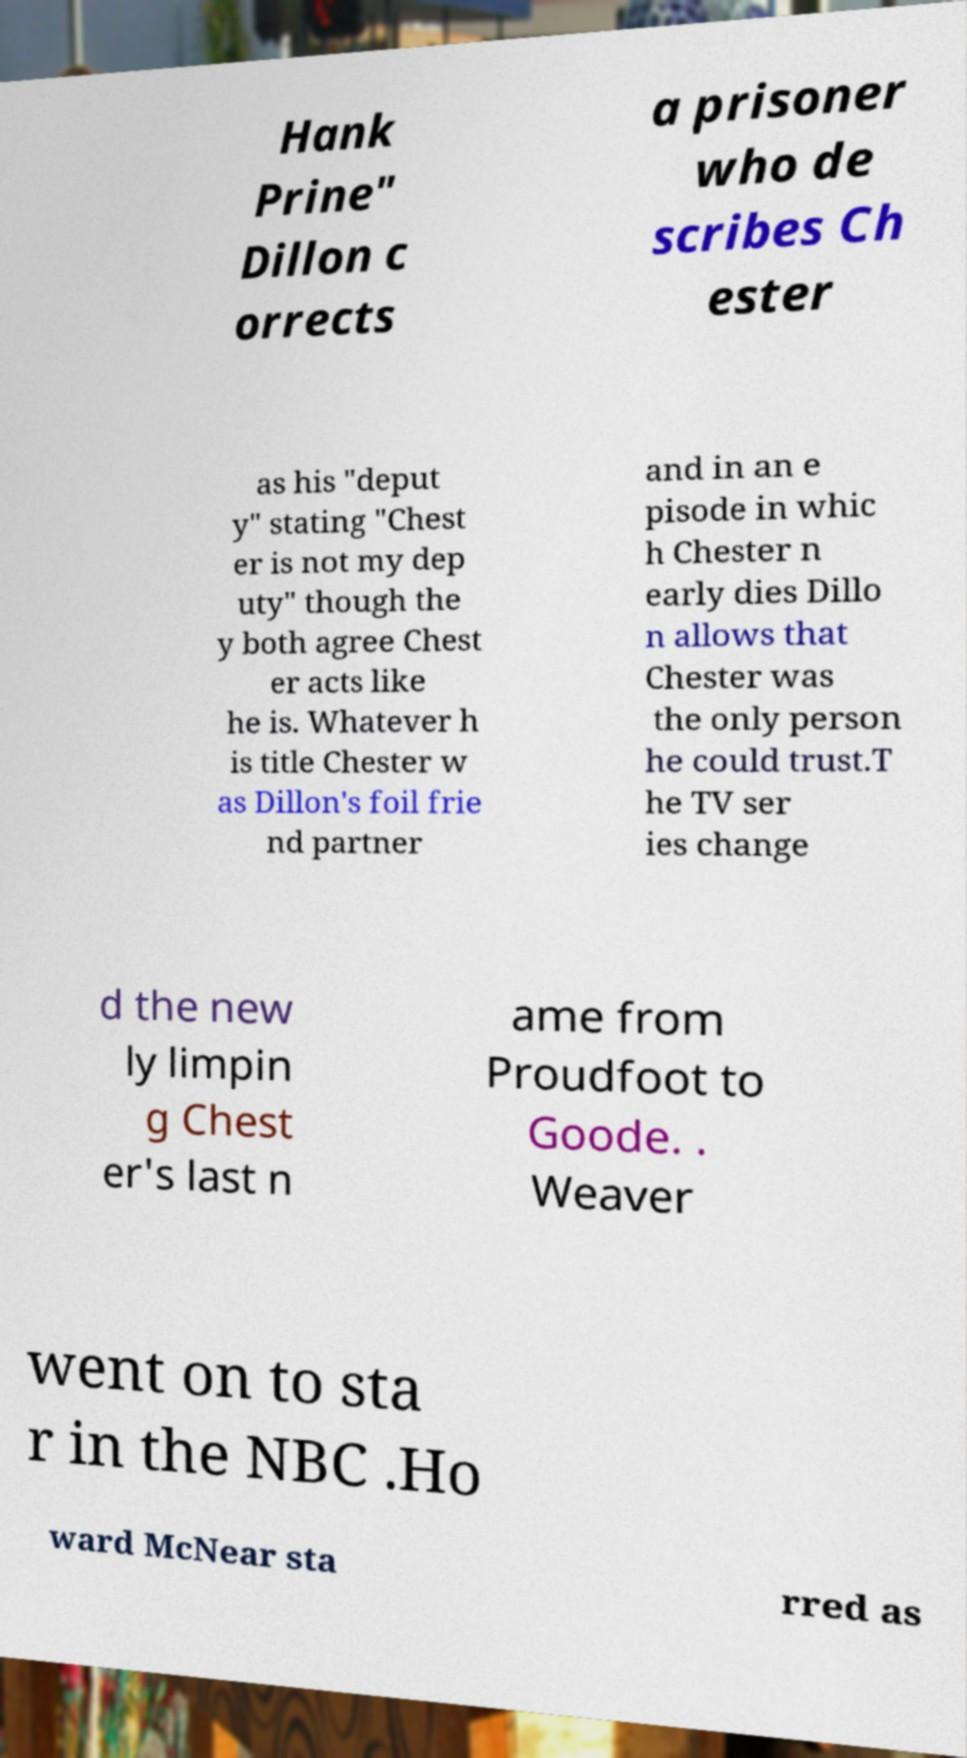Please identify and transcribe the text found in this image. Hank Prine" Dillon c orrects a prisoner who de scribes Ch ester as his "deput y" stating "Chest er is not my dep uty" though the y both agree Chest er acts like he is. Whatever h is title Chester w as Dillon's foil frie nd partner and in an e pisode in whic h Chester n early dies Dillo n allows that Chester was the only person he could trust.T he TV ser ies change d the new ly limpin g Chest er's last n ame from Proudfoot to Goode. . Weaver went on to sta r in the NBC .Ho ward McNear sta rred as 